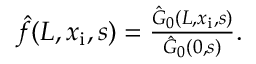<formula> <loc_0><loc_0><loc_500><loc_500>\begin{array} { r } { \hat { f } ( L , x _ { i } , s ) = \frac { \hat { G } _ { 0 } ( L , x _ { i } , s ) } { \hat { G } _ { 0 } ( 0 , s ) } . } \end{array}</formula> 